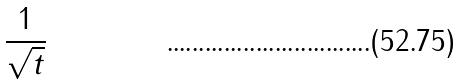Convert formula to latex. <formula><loc_0><loc_0><loc_500><loc_500>\frac { 1 } { \sqrt { t } }</formula> 